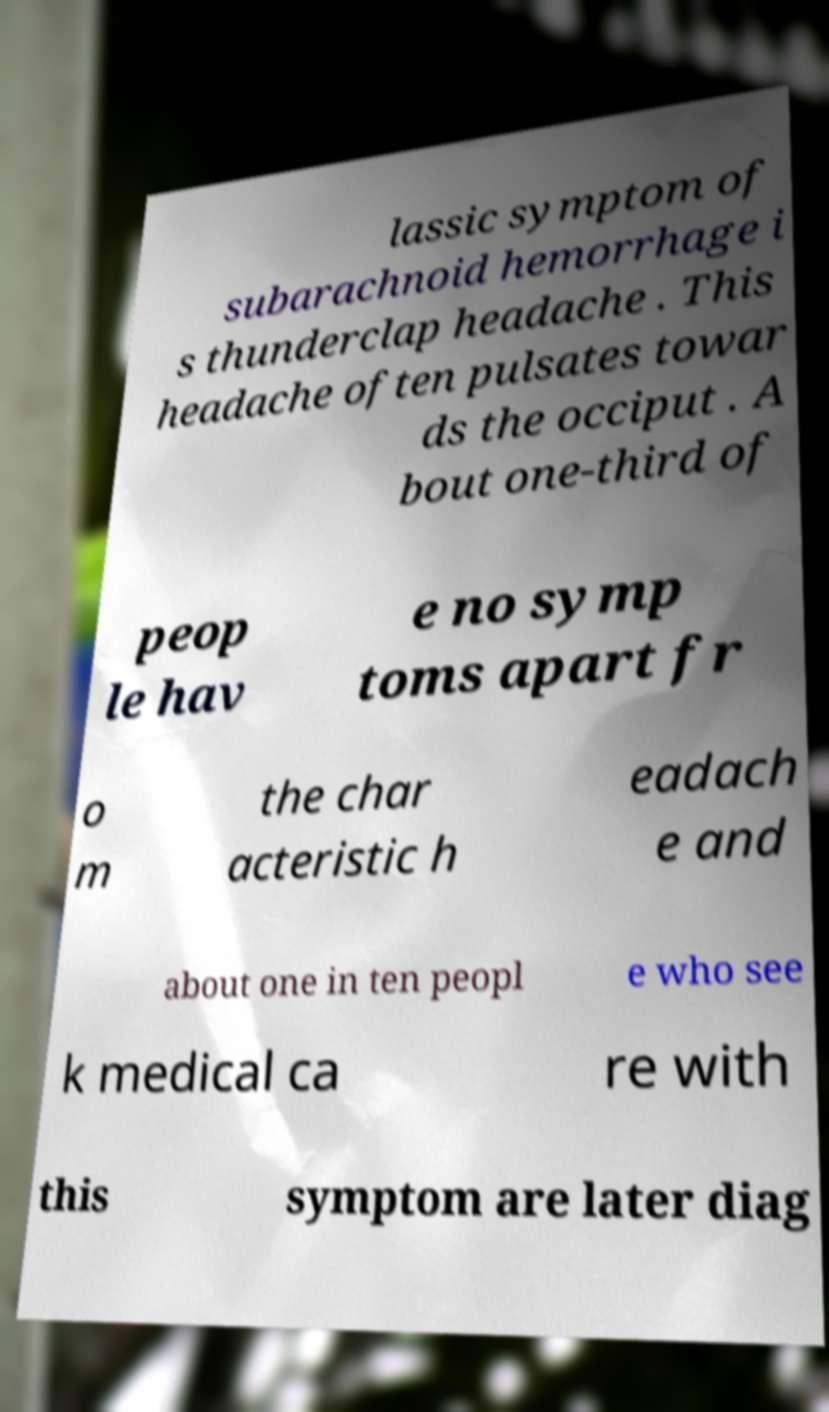I need the written content from this picture converted into text. Can you do that? lassic symptom of subarachnoid hemorrhage i s thunderclap headache . This headache often pulsates towar ds the occiput . A bout one-third of peop le hav e no symp toms apart fr o m the char acteristic h eadach e and about one in ten peopl e who see k medical ca re with this symptom are later diag 